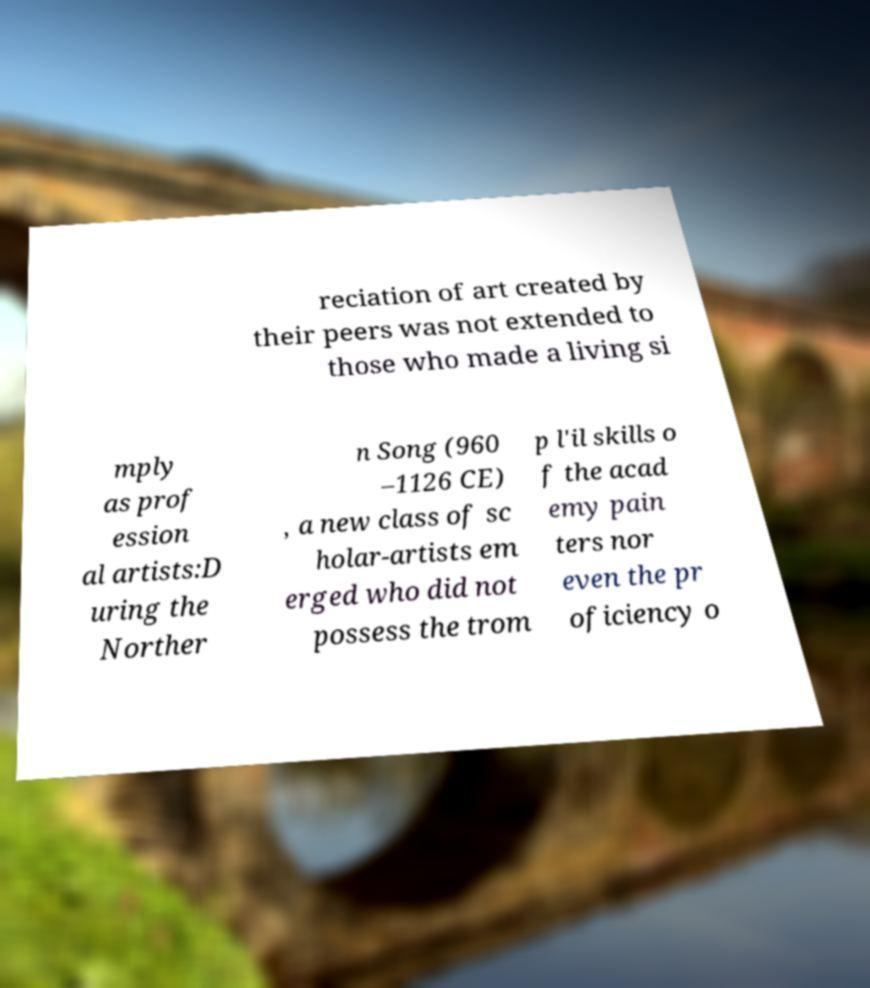Please identify and transcribe the text found in this image. reciation of art created by their peers was not extended to those who made a living si mply as prof ession al artists:D uring the Norther n Song (960 –1126 CE) , a new class of sc holar-artists em erged who did not possess the trom p l'il skills o f the acad emy pain ters nor even the pr oficiency o 